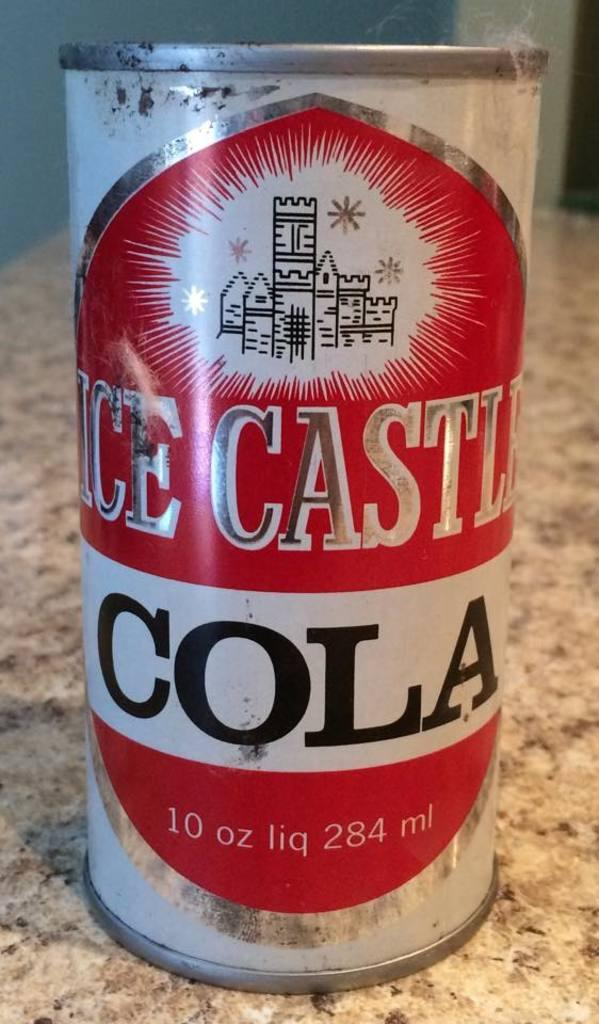Provide a one-sentence caption for the provided image. A can of cola sitting on a marble bench top. 